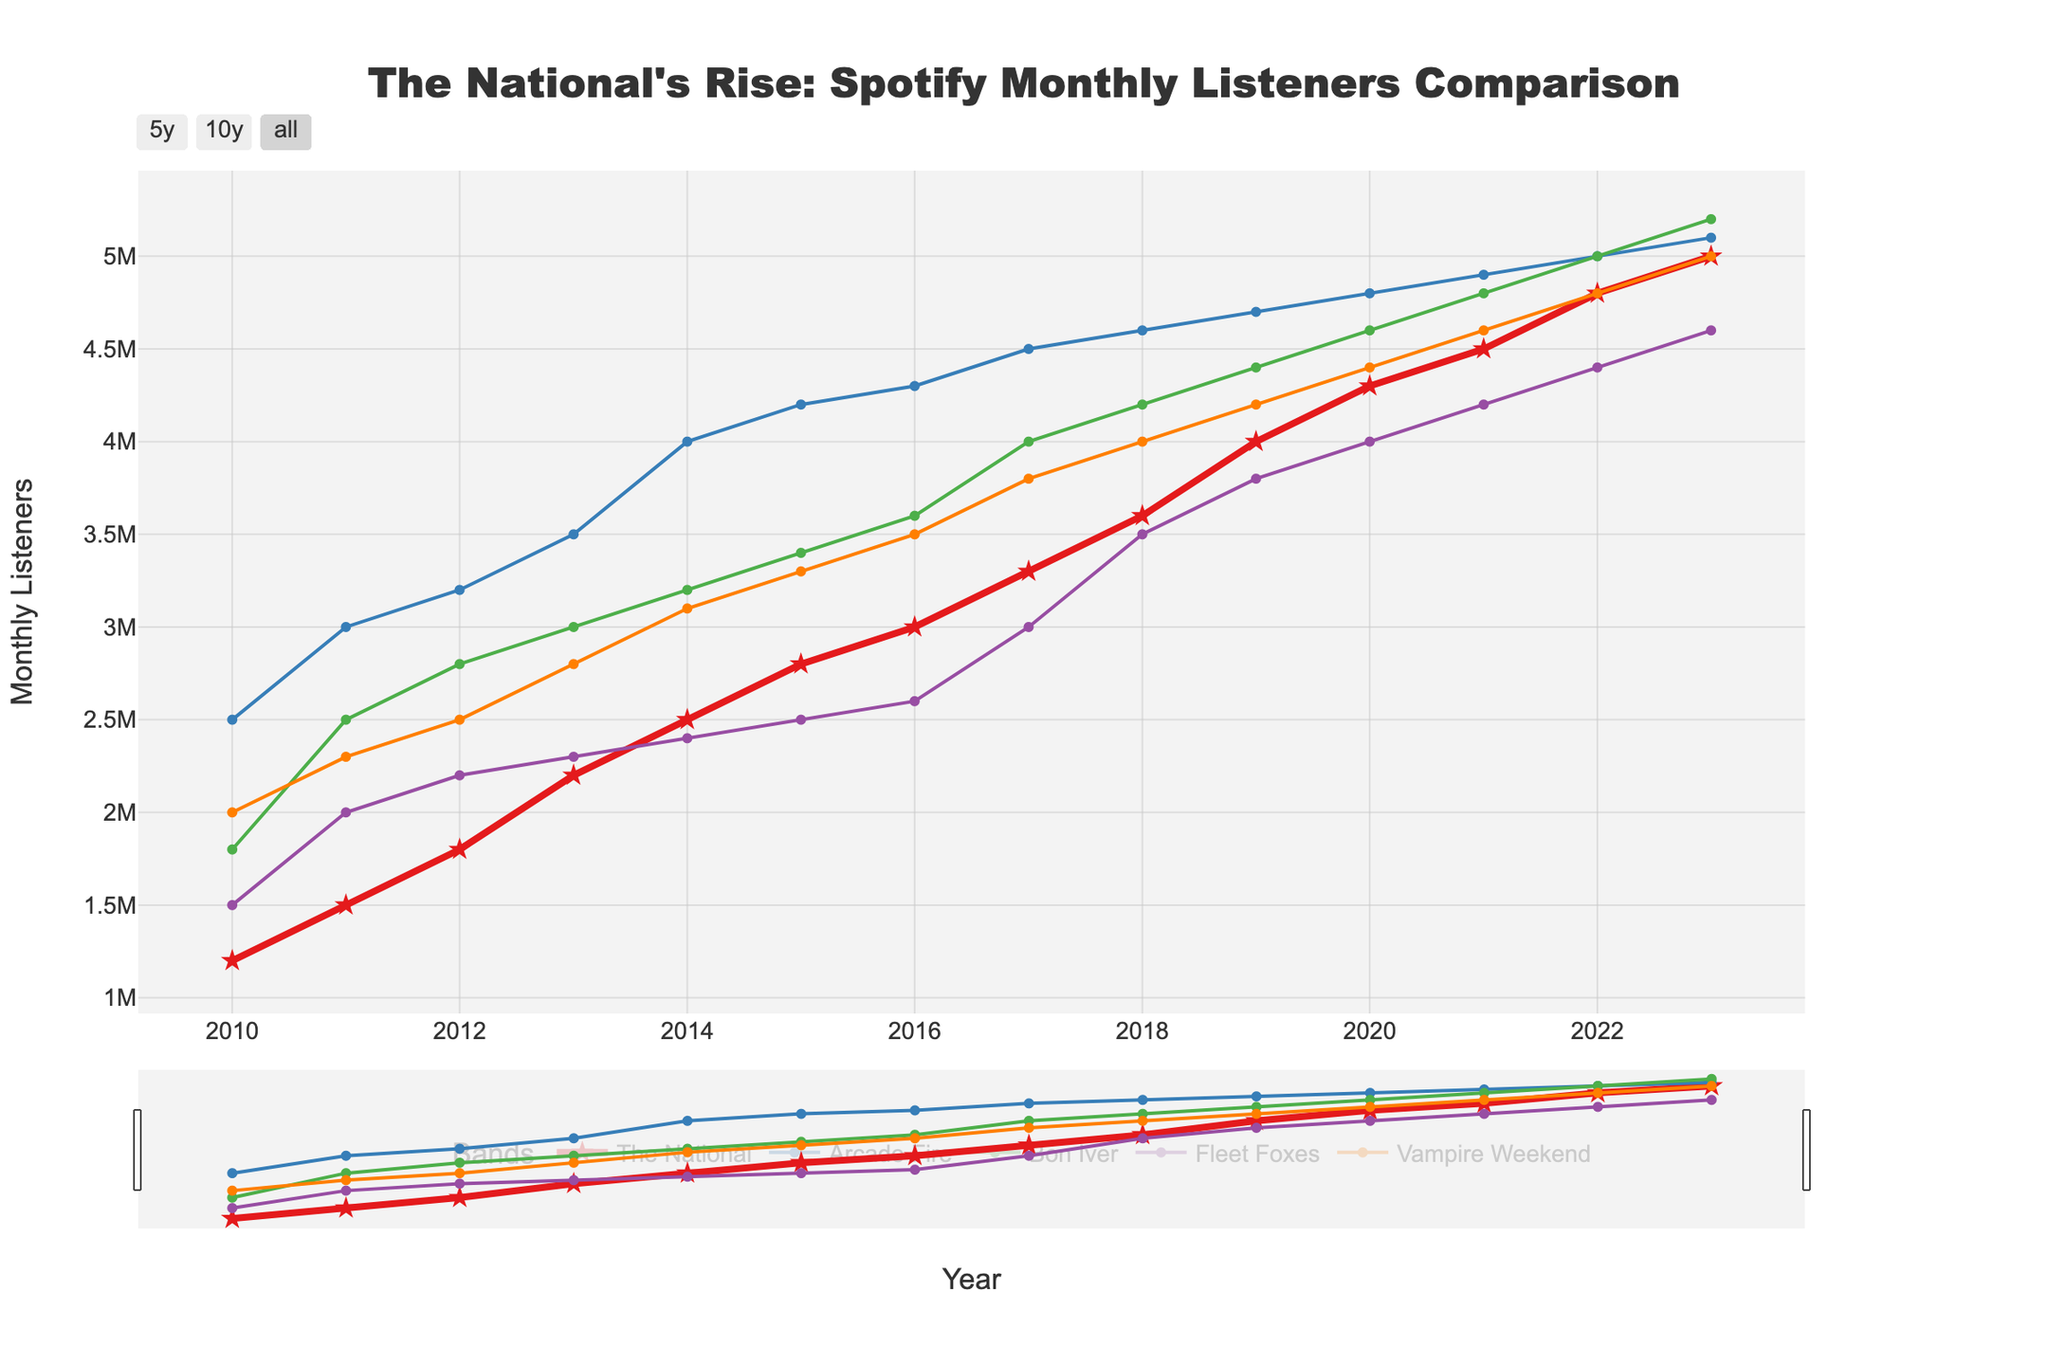What trend do you observe in Spotify monthly listeners for The National from 2010 to 2023? By looking at the line representing The National, there's a steady increase in the number of Spotify monthly listeners over the years from 2010 to 2023.
Answer: Steady increase How does the number of Spotify monthly listeners for The National in 2023 compare to Arcade Fire? In 2023, The National has 5,000,000 monthly listeners, and Arcade Fire has 5,100,000 monthly listeners, making Arcade Fire's listeners slightly higher.
Answer: Slightly lower In which year did The National surpass Fleet Foxes in monthly listeners? We look for the year where The National's line crosses above Fleet Foxes' line. This first happens in 2013.
Answer: 2013 What is the difference in Spotify monthly listeners between The National and Bon Iver in 2020? In 2020, The National has 4,300,000 listeners and Bon Iver has 4,600,000 listeners. The difference is 4,600,000 - 4,300,000 = 300,000.
Answer: 300,000 Compare the growth rate of Spotify monthly listeners for The National and Vampire Weekend from 2010 to 2023. The National's listeners grew from 1,200,000 to 5,000,000, an increase of 3,800,000. Vampire Weekend's listeners grew from 2,000,000 to 5,000,000, an increase of 3,000,000. The National's growth rate is higher.
Answer: The National's growth rate is higher What is the average number of Spotify monthly listeners for The National across all displayed years? Sum of monthly listeners from 2010 to 2023 is 1200000 + 1500000 + 1800000 + 2200000 + 2500000 + 2800000 + 3000000 + 3300000 + 3600000 + 4000000 + 4300000 + 4500000 + 4800000 + 5000000 = 46600000. There are 14 years, so the average is 46600000 / 14 ≈ 3,328,571.
Answer: 3,328,571 Which band had the highest number of Spotify monthly listeners in 2015? Observing the plot, Arcade Fire had the highest number with 4,200,000 listeners in 2015.
Answer: Arcade Fire What year did Bon Iver first surpass 4,000,000 monthly listeners? By following the Bon Iver line, the first occurrence above 4,000,000 is in 2017.
Answer: 2017 How did Bon Iver's listeners change from 2011 to 2013? In 2011, Bon Iver had 2,500,000 listeners, and in 2013, they had 3,000,000. The increase is 3,000,000 - 2,500,000 = 500,000.
Answer: Increased by 500,000 When did Arcade Fire experience its most significant increase in Spotify monthly listeners over one year, and by how much? Looking at the Arcade Fire line, the most significant one-year increase happened between 2010 (2,500,000) and 2011 (3,000,000), an increase of 3,000,000 - 2,500,000 = 500,000.
Answer: 2010 to 2011 by 500,000 